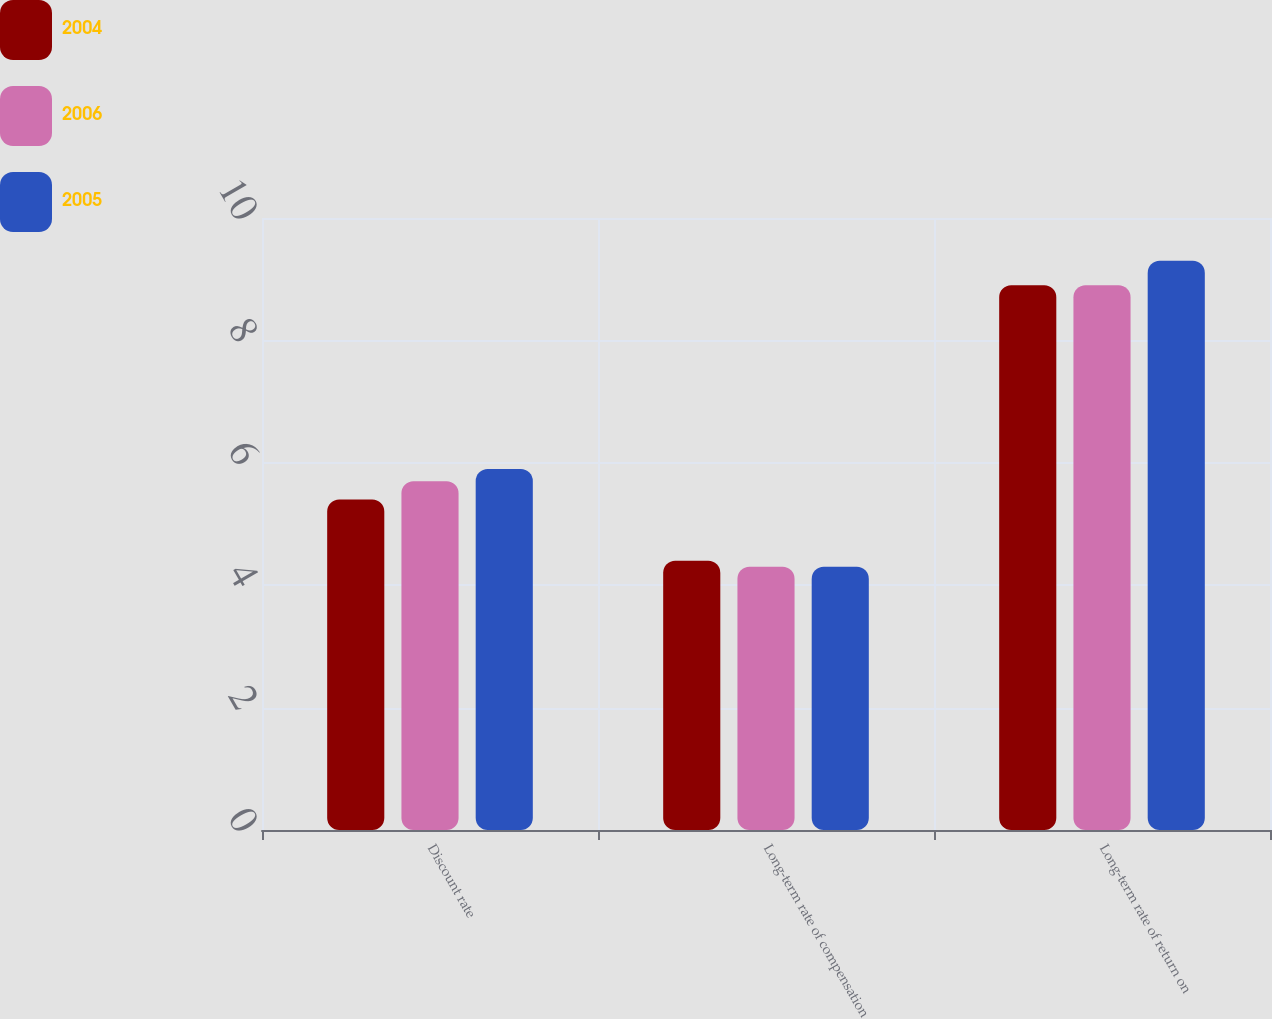Convert chart. <chart><loc_0><loc_0><loc_500><loc_500><stacked_bar_chart><ecel><fcel>Discount rate<fcel>Long-term rate of compensation<fcel>Long-term rate of return on<nl><fcel>2004<fcel>5.4<fcel>4.4<fcel>8.9<nl><fcel>2006<fcel>5.7<fcel>4.3<fcel>8.9<nl><fcel>2005<fcel>5.9<fcel>4.3<fcel>9.3<nl></chart> 